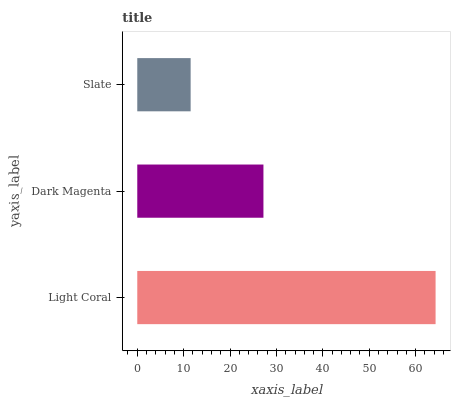Is Slate the minimum?
Answer yes or no. Yes. Is Light Coral the maximum?
Answer yes or no. Yes. Is Dark Magenta the minimum?
Answer yes or no. No. Is Dark Magenta the maximum?
Answer yes or no. No. Is Light Coral greater than Dark Magenta?
Answer yes or no. Yes. Is Dark Magenta less than Light Coral?
Answer yes or no. Yes. Is Dark Magenta greater than Light Coral?
Answer yes or no. No. Is Light Coral less than Dark Magenta?
Answer yes or no. No. Is Dark Magenta the high median?
Answer yes or no. Yes. Is Dark Magenta the low median?
Answer yes or no. Yes. Is Light Coral the high median?
Answer yes or no. No. Is Light Coral the low median?
Answer yes or no. No. 